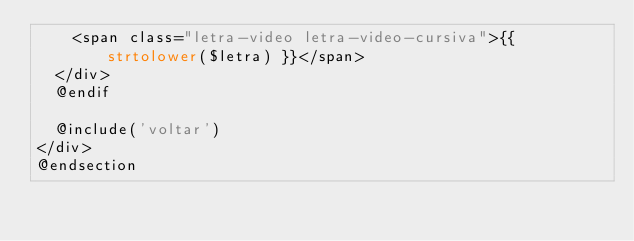Convert code to text. <code><loc_0><loc_0><loc_500><loc_500><_PHP_>		<span class="letra-video letra-video-cursiva">{{ strtolower($letra) }}</span>
	</div>
	@endif

	@include('voltar')
</div>
@endsection</code> 